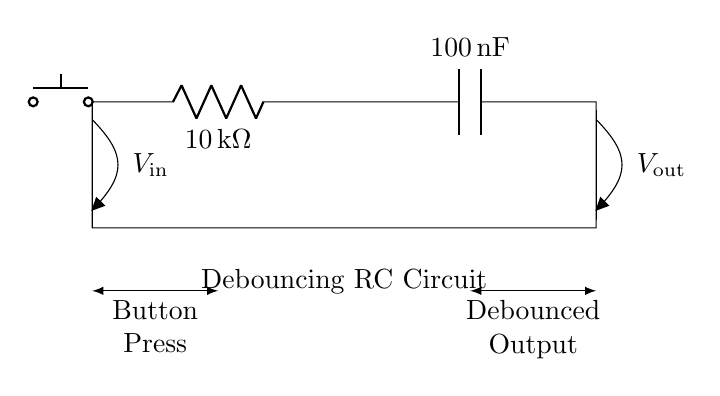What type of components are used in the circuit? The circuit consists of a resistor and a capacitor, as indicated by the labels R and C, respectively.
Answer: Resistor and capacitor What is the resistance value of the resistor? The resistor is labeled with a value of ten kilo-ohms, shown in the diagram.
Answer: Ten kilo-ohms What is the capacitance value of the capacitor? The capacitor is labeled with a value of one hundred nano-farads, which is explicitly indicated in the diagram.
Answer: One hundred nano-farads How does the button affect the output signal? When the button is pressed, it generates a change in voltage at the output, momentarily altering the state. This setup is intended to eliminate noise during the transition.
Answer: It debounces the output signal What is the purpose of this RC circuit? The purpose of the RC circuit is to debounce the signal from a physical button, filtering out noise during button presses. This is commonly used in hardware interfaces to ensure reliable input detection.
Answer: To debounce button inputs What happens to the output voltage when the button is pressed? When the button is pressed, an input voltage change occurs, causing the capacitor to charge and the output voltage to rise gradually instead of instantaneously, thereby delaying the output.
Answer: Output rises gradually What is the input voltage represented as in the diagram? The input voltage is labeled with a symbol V in the diagram, located at the left side of the circuit, where the button connects.
Answer: V in 